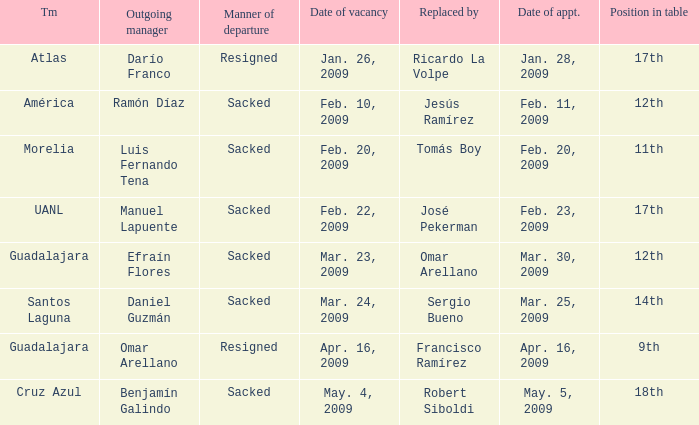What is Manner of Departure, when Outgoing Manager is "Luis Fernando Tena"? Sacked. 